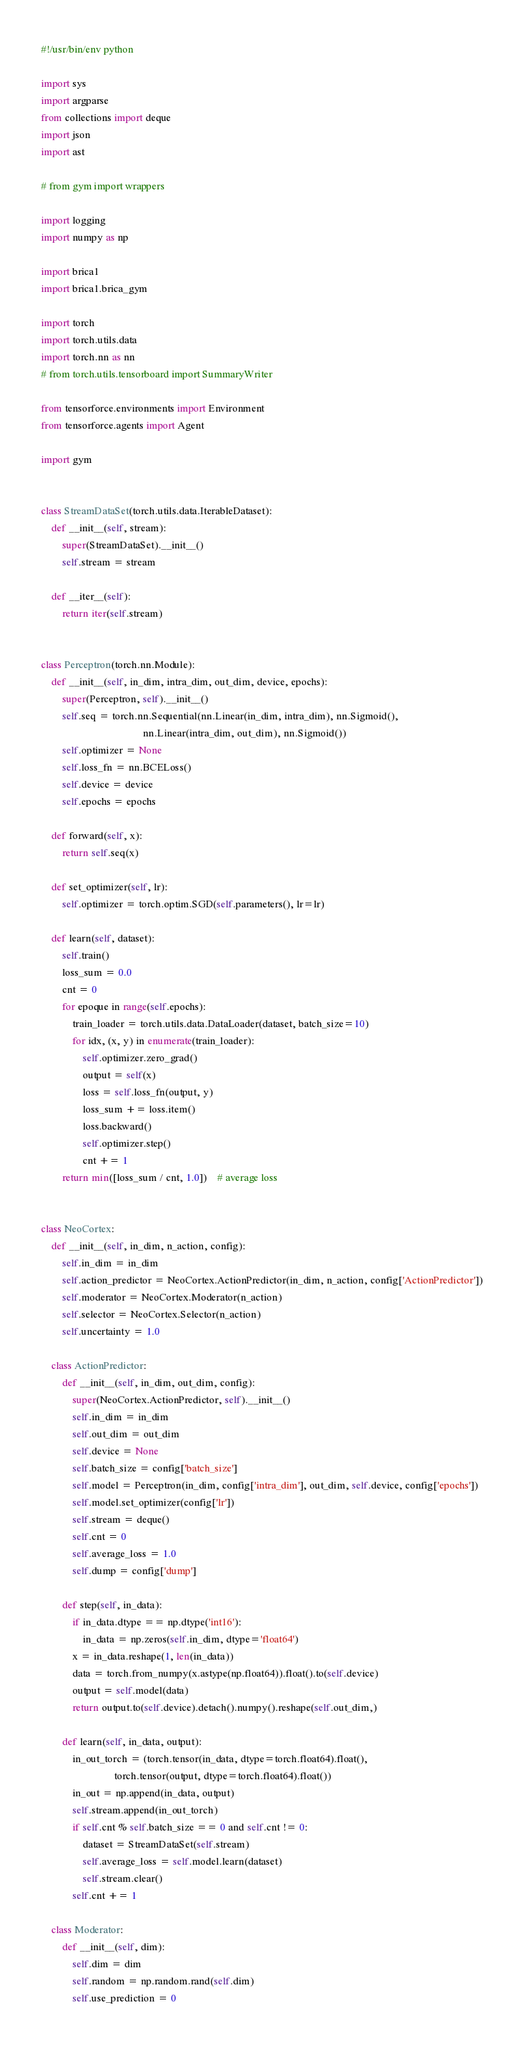<code> <loc_0><loc_0><loc_500><loc_500><_Python_>#!/usr/bin/env python

import sys
import argparse
from collections import deque
import json
import ast

# from gym import wrappers

import logging
import numpy as np

import brica1
import brica1.brica_gym

import torch
import torch.utils.data
import torch.nn as nn
# from torch.utils.tensorboard import SummaryWriter

from tensorforce.environments import Environment
from tensorforce.agents import Agent

import gym


class StreamDataSet(torch.utils.data.IterableDataset):
    def __init__(self, stream):
        super(StreamDataSet).__init__()
        self.stream = stream

    def __iter__(self):
        return iter(self.stream)


class Perceptron(torch.nn.Module):
    def __init__(self, in_dim, intra_dim, out_dim, device, epochs):
        super(Perceptron, self).__init__()
        self.seq = torch.nn.Sequential(nn.Linear(in_dim, intra_dim), nn.Sigmoid(),
                                       nn.Linear(intra_dim, out_dim), nn.Sigmoid())
        self.optimizer = None
        self.loss_fn = nn.BCELoss()
        self.device = device
        self.epochs = epochs

    def forward(self, x):
        return self.seq(x)

    def set_optimizer(self, lr):
        self.optimizer = torch.optim.SGD(self.parameters(), lr=lr)

    def learn(self, dataset):
        self.train()
        loss_sum = 0.0
        cnt = 0
        for epoque in range(self.epochs):
            train_loader = torch.utils.data.DataLoader(dataset, batch_size=10)
            for idx, (x, y) in enumerate(train_loader):
                self.optimizer.zero_grad()
                output = self(x)
                loss = self.loss_fn(output, y)
                loss_sum += loss.item()
                loss.backward()
                self.optimizer.step()
                cnt += 1
        return min([loss_sum / cnt, 1.0])    # average loss


class NeoCortex:
    def __init__(self, in_dim, n_action, config):
        self.in_dim = in_dim
        self.action_predictor = NeoCortex.ActionPredictor(in_dim, n_action, config['ActionPredictor'])
        self.moderator = NeoCortex.Moderator(n_action)
        self.selector = NeoCortex.Selector(n_action)
        self.uncertainty = 1.0

    class ActionPredictor:
        def __init__(self, in_dim, out_dim, config):
            super(NeoCortex.ActionPredictor, self).__init__()
            self.in_dim = in_dim
            self.out_dim = out_dim
            self.device = None
            self.batch_size = config['batch_size']
            self.model = Perceptron(in_dim, config['intra_dim'], out_dim, self.device, config['epochs'])
            self.model.set_optimizer(config['lr'])
            self.stream = deque()
            self.cnt = 0
            self.average_loss = 1.0
            self.dump = config['dump']

        def step(self, in_data):
            if in_data.dtype == np.dtype('int16'):
                in_data = np.zeros(self.in_dim, dtype='float64')
            x = in_data.reshape(1, len(in_data))
            data = torch.from_numpy(x.astype(np.float64)).float().to(self.device)
            output = self.model(data)
            return output.to(self.device).detach().numpy().reshape(self.out_dim,)

        def learn(self, in_data, output):
            in_out_torch = (torch.tensor(in_data, dtype=torch.float64).float(),
                            torch.tensor(output, dtype=torch.float64).float())
            in_out = np.append(in_data, output)
            self.stream.append(in_out_torch)
            if self.cnt % self.batch_size == 0 and self.cnt != 0:
                dataset = StreamDataSet(self.stream)
                self.average_loss = self.model.learn(dataset)
                self.stream.clear()
            self.cnt += 1

    class Moderator:
        def __init__(self, dim):
            self.dim = dim
            self.random = np.random.rand(self.dim)
            self.use_prediction = 0
</code> 